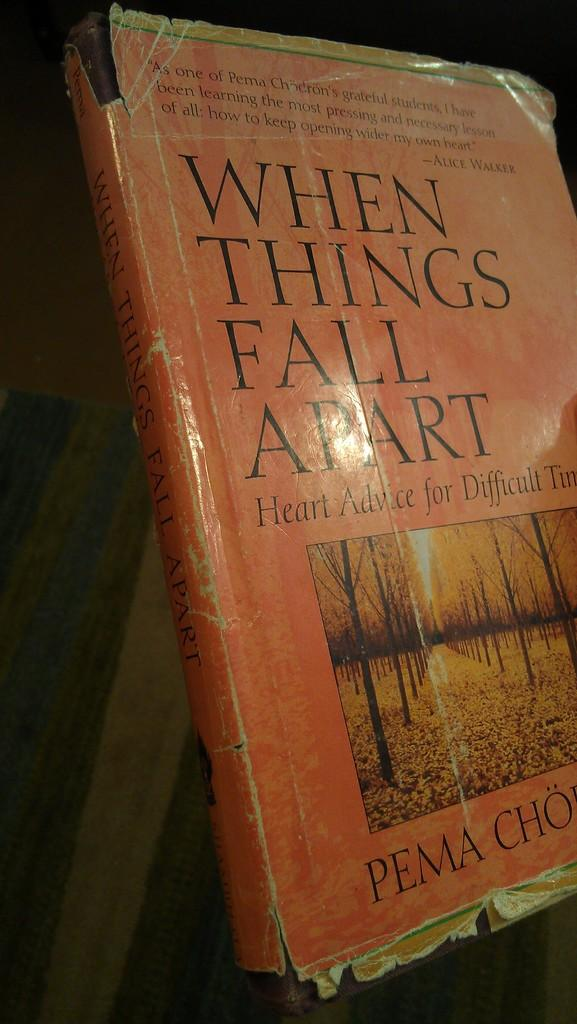<image>
Offer a succinct explanation of the picture presented. A book that is titled When Things Fall Apart. 